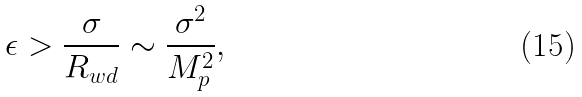<formula> <loc_0><loc_0><loc_500><loc_500>\epsilon > \frac { \sigma } { R _ { w d } } \sim \frac { \sigma ^ { 2 } } { M ^ { 2 } _ { p } } ,</formula> 